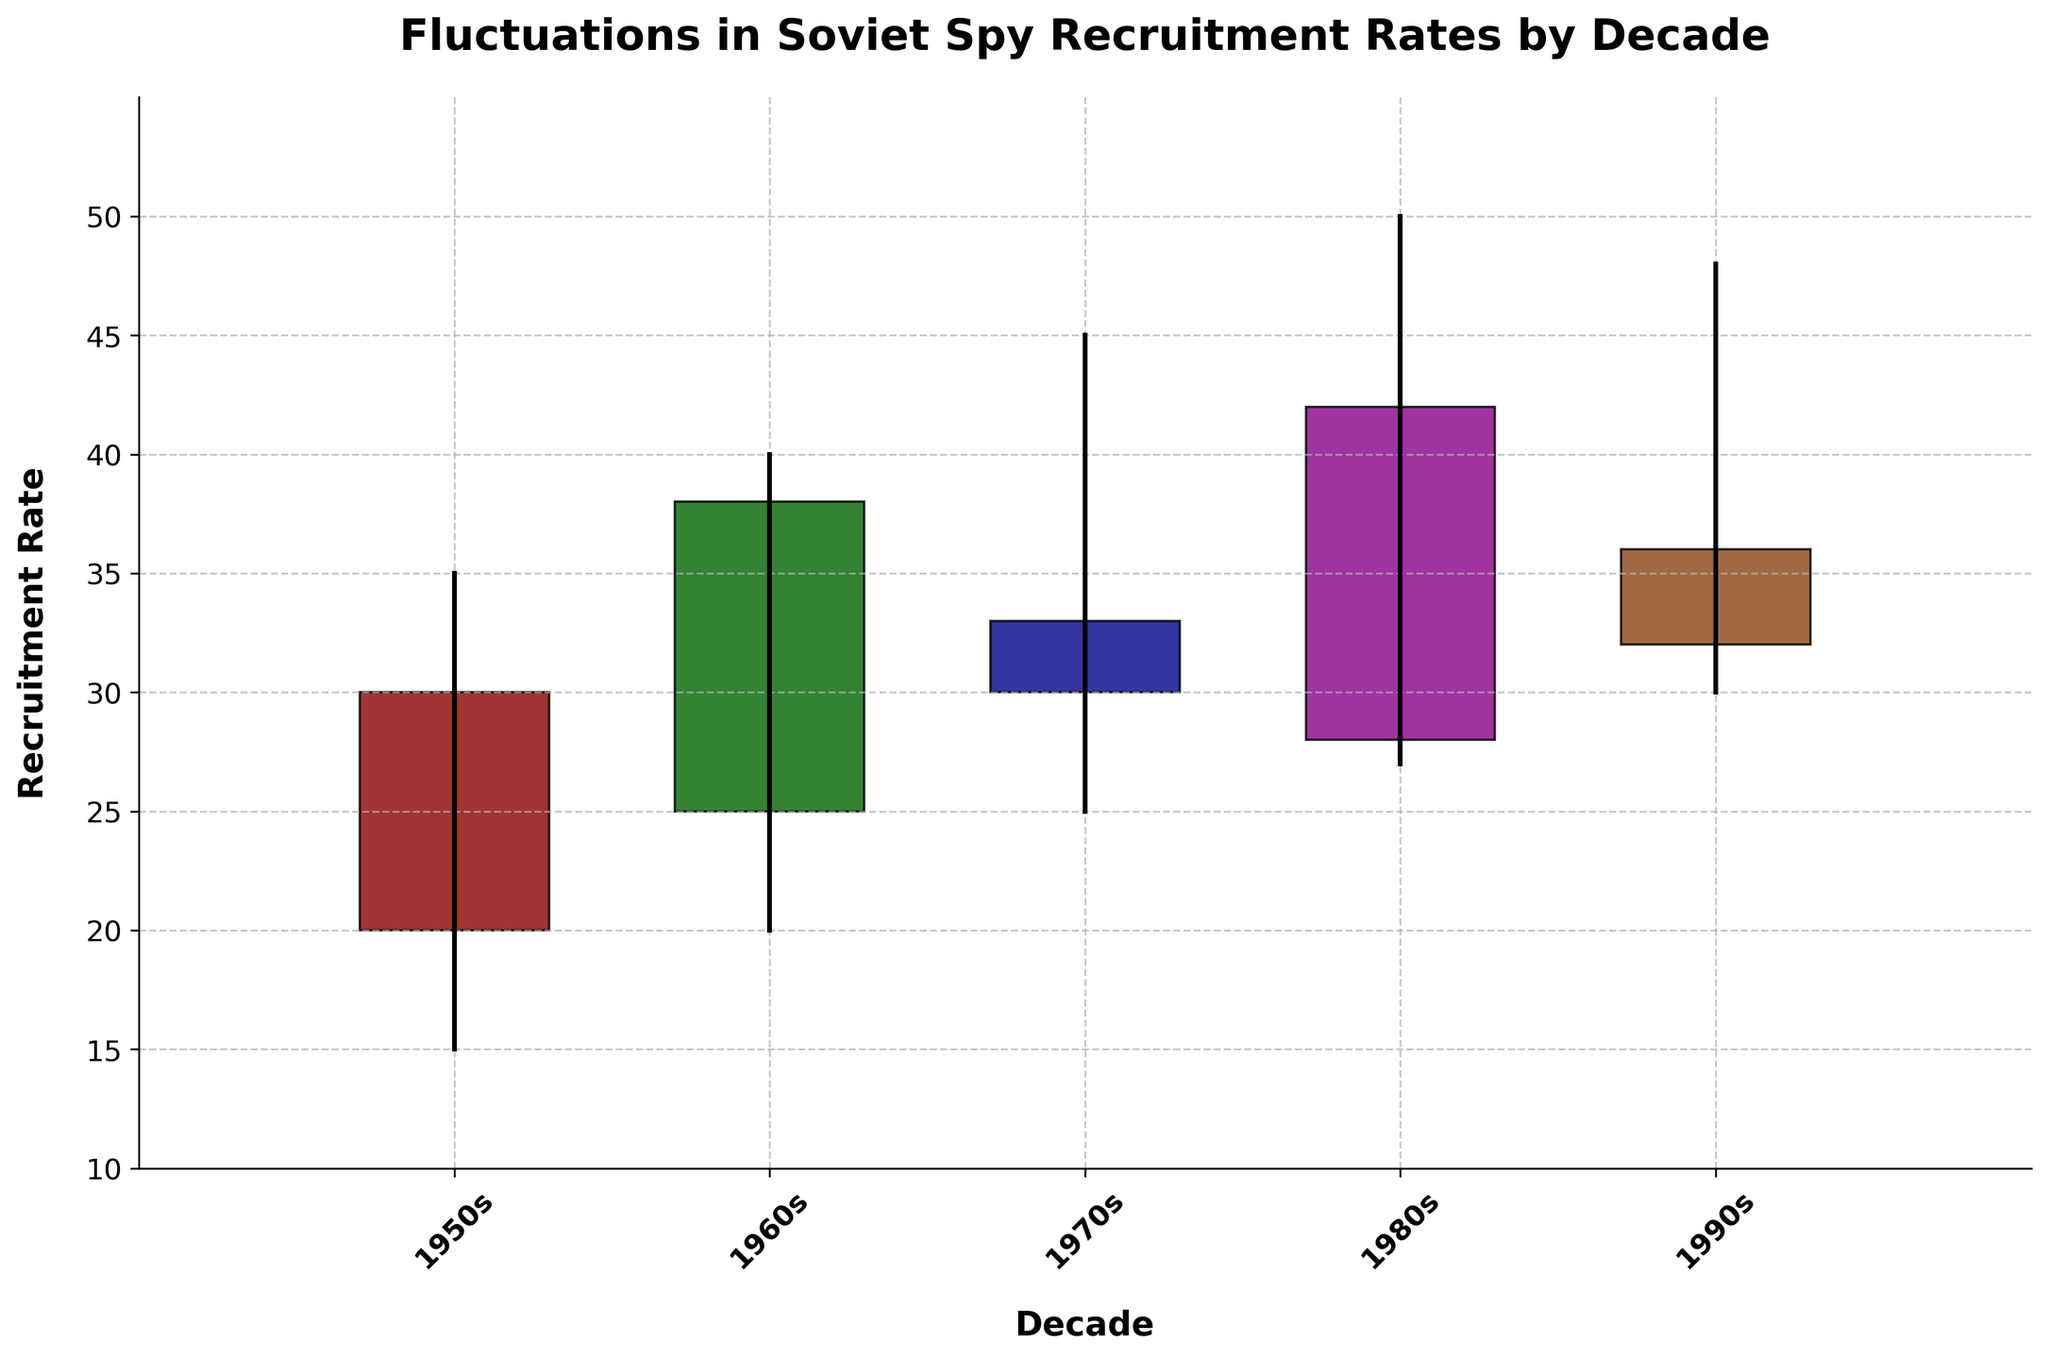What is the title of the figure? The title of the chart is usually found at the top center of the figure, indicating what the chart represents. In this case, it clearly states: "Fluctuations in Soviet Spy Recruitment Rates by Decade".
Answer: "Fluctuations in Soviet Spy Recruitment Rates by Decade" How many decades are represented in the figure? By observing the x-axis labels, one can see distinct markings for different decades, specifically: 1950s, 1960s, 1970s, 1980s, and 1990s, making a total of five.
Answer: Five Which decade shows the lowest recruitment rate? To determine the decade with the lowest recruitment rate, observe the 'Low' values for each candlestick. The 1950s have the lowest 'Low' value, which is 15.
Answer: 1950s What color represents the 1980s in the figure? In candlestick plots such as this, colors can identify different decades or periods. The question specifies 1980s, which is colored in one of the repeated color schemes such as red, green, or another hue. According to the provided code, the 1980s use the fourth color in the list, which is magenta.
Answer: Magenta During which decade was the difference between the high and low recruitment rates the largest? Calculate the difference between the high and low values for each decade and compare them. For the 1980s, the difference is 50 - 27 = 23, which is the largest compared to all other decades.
Answer: 1980s Which decade shows an upward trend in recruitment rates? An upward trend in candlestick plot is when the 'Close' value is higher than the 'Open' value. Both 1960s and 1980s show such trends where close values (38 and 42, respectively) are higher than open values (25 and 28).
Answer: 1960s and 1980s Is the recruitment rate in the 1990s higher or lower than that in the 1980s? Compare the 'Close' values of the two decades. The close value in the 1990s is 36, which is lower compared to the close value of 42 in the 1980s.
Answer: Lower What is the average 'Open' value for all decades? Sum the 'Open' values of all decades (20 + 25 + 30 + 28 + 32 = 135) and divide by the number of decades (5). The average 'Open' value is 135 / 5, which equals 27.
Answer: 27 What is the main difference between the recruitment rates of the 1970s and 1980s? Compare the 'Open', 'High', 'Low', and 'Close' values of the 1970s (30, 45, 25, 33) with those of the 1980s (28, 50, 27, 42). The close value change shows an upward trend from 33 in the 1970s to 42 in the 1980s while the high value also significantly increased from 45 to 50.
Answer: The 1980s saw a higher close rate and significant increase in high values 